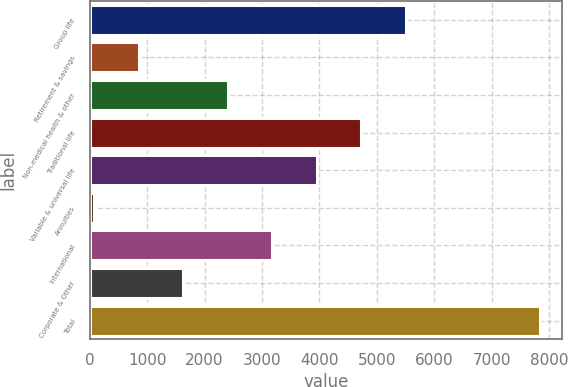Convert chart to OTSL. <chart><loc_0><loc_0><loc_500><loc_500><bar_chart><fcel>Group life<fcel>Retirement & savings<fcel>Non-medical health & other<fcel>Traditional life<fcel>Variable & universal life<fcel>Annuities<fcel>International<fcel>Corporate & Other<fcel>Total<nl><fcel>5509.4<fcel>852.2<fcel>2404.6<fcel>4733.2<fcel>3957<fcel>76<fcel>3180.8<fcel>1628.4<fcel>7838<nl></chart> 